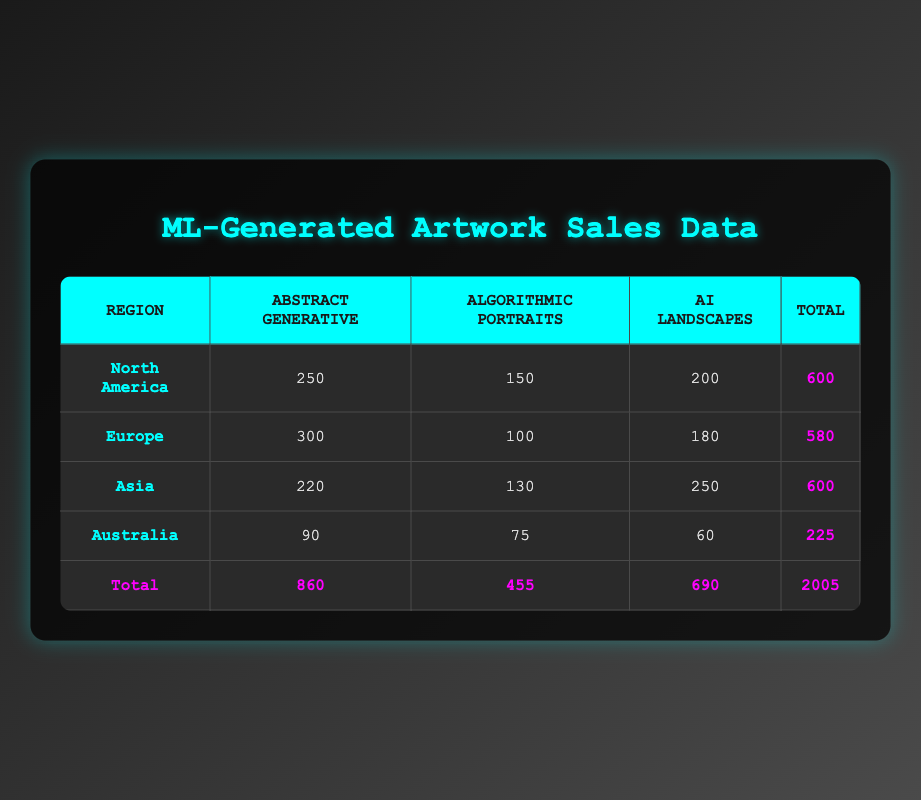What is the total sales of AI Landscapes in Europe? The sales of AI Landscapes in Europe is listed directly in the table as 180.
Answer: 180 Which region has the highest sales in Abstract Generative artworks? In the table, North America has 250, Europe has 300, Asia has 220, and Australia has 90. The highest value is from Europe.
Answer: Europe What is the difference in total sales between North America and Australia? The total sales for North America is 600 and for Australia, it is 225. So the difference is 600 - 225 = 375.
Answer: 375 Are the total sales in Asia greater than those in Europe? The total sales in Asia is 600 and in Europe it is 580. Since 600 is greater than 580, the statement is true.
Answer: Yes What is the average sales of Algorithmic Portraits across all regions? The sales figures for Algorithmic Portraits are 150 (North America), 100 (Europe), 130 (Asia), and 75 (Australia). Summing these gives 150 + 100 + 130 + 75 = 455. There are 4 regions, so the average is 455 / 4 = 113.75.
Answer: 113.75 Which artwork type has the least total sales, and what is that amount? To find the least total sales, we total each type: Abstract Generative = 860, Algorithmic Portraits = 455, AI Landscapes = 690. The least is for Algorithmic Portraits which totals 455.
Answer: Algorithmic Portraits, 455 What percentage of total sales in North America are from AI Landscapes? The total sales in North America is 600, and the sales for AI Landscapes is 200. The percentage is calculated as (200 / 600) * 100 = 33.33%.
Answer: 33.33% How many more sales of Abstract Generative artworks are there in North America than in Australia? Sales in North America for Abstract Generative is 250 and for Australia, it is 90. The difference is 250 - 90 = 160.
Answer: 160 What is the total sales for all regions combined? The total sales for all regions is listed at the bottom of the table as 2005, which is the sum of all regional sales across all artwork types.
Answer: 2005 